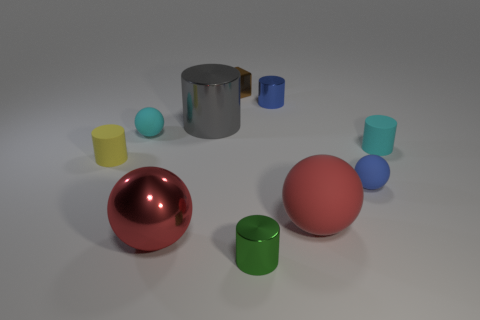Subtract all metallic balls. How many balls are left? 3 Subtract all cyan balls. How many balls are left? 3 Subtract 1 balls. How many balls are left? 3 Subtract all cyan cubes. Subtract all cyan cylinders. How many cubes are left? 1 Subtract all yellow balls. How many green cylinders are left? 1 Subtract all yellow things. Subtract all tiny blue shiny cylinders. How many objects are left? 8 Add 3 blue metallic cylinders. How many blue metallic cylinders are left? 4 Add 6 large red rubber spheres. How many large red rubber spheres exist? 7 Subtract 1 cyan balls. How many objects are left? 9 Subtract all cubes. How many objects are left? 9 